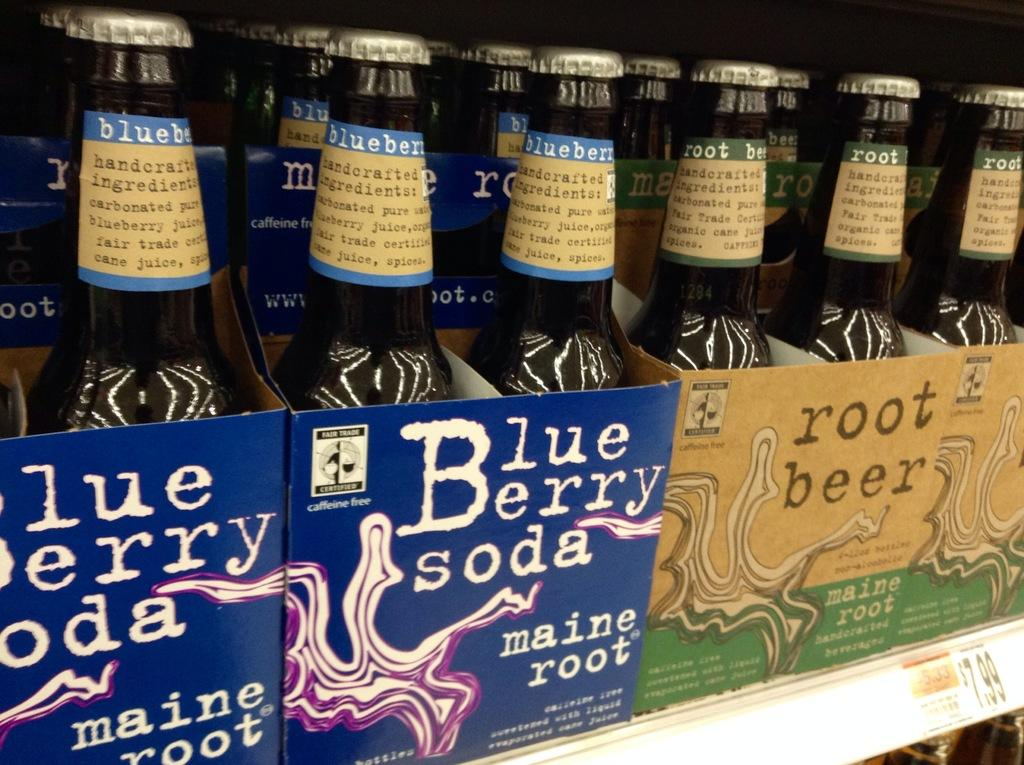<image>
Provide a brief description of the given image. packs of soda next to each other with one that is blueberry soda 